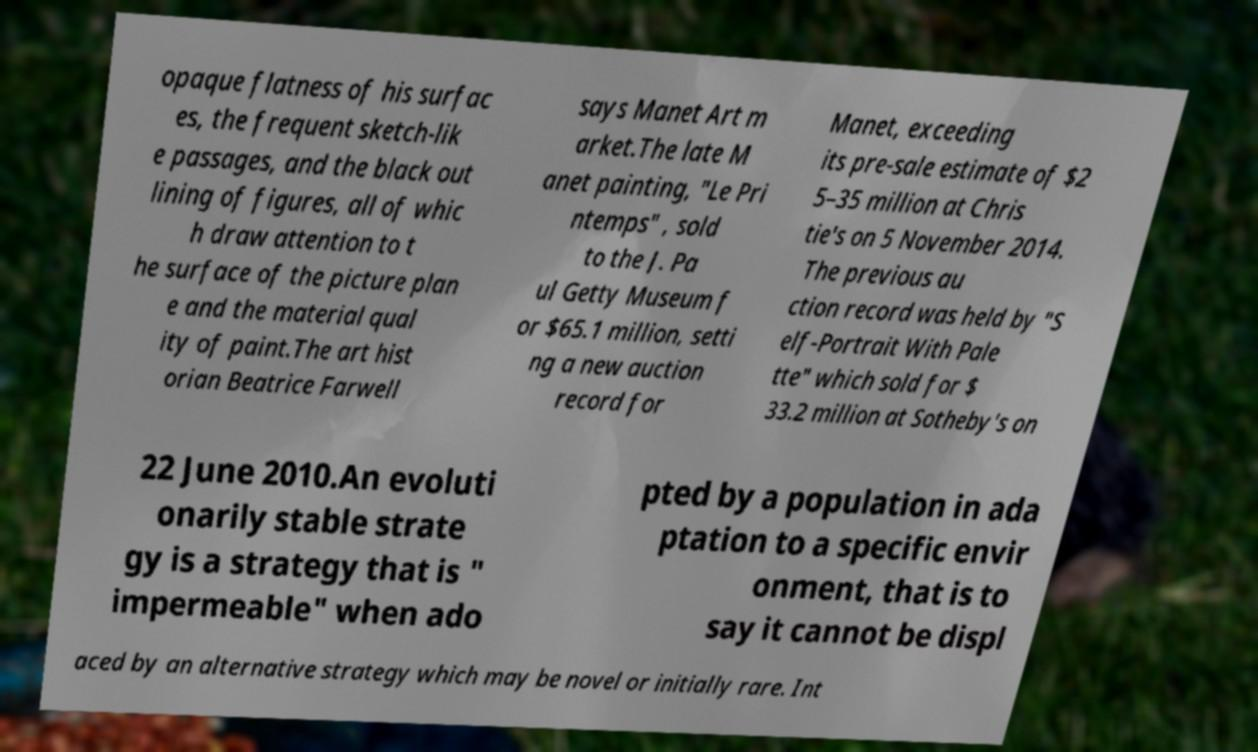There's text embedded in this image that I need extracted. Can you transcribe it verbatim? opaque flatness of his surfac es, the frequent sketch-lik e passages, and the black out lining of figures, all of whic h draw attention to t he surface of the picture plan e and the material qual ity of paint.The art hist orian Beatrice Farwell says Manet Art m arket.The late M anet painting, "Le Pri ntemps" , sold to the J. Pa ul Getty Museum f or $65.1 million, setti ng a new auction record for Manet, exceeding its pre-sale estimate of $2 5–35 million at Chris tie's on 5 November 2014. The previous au ction record was held by "S elf-Portrait With Pale tte" which sold for $ 33.2 million at Sotheby's on 22 June 2010.An evoluti onarily stable strate gy is a strategy that is " impermeable" when ado pted by a population in ada ptation to a specific envir onment, that is to say it cannot be displ aced by an alternative strategy which may be novel or initially rare. Int 